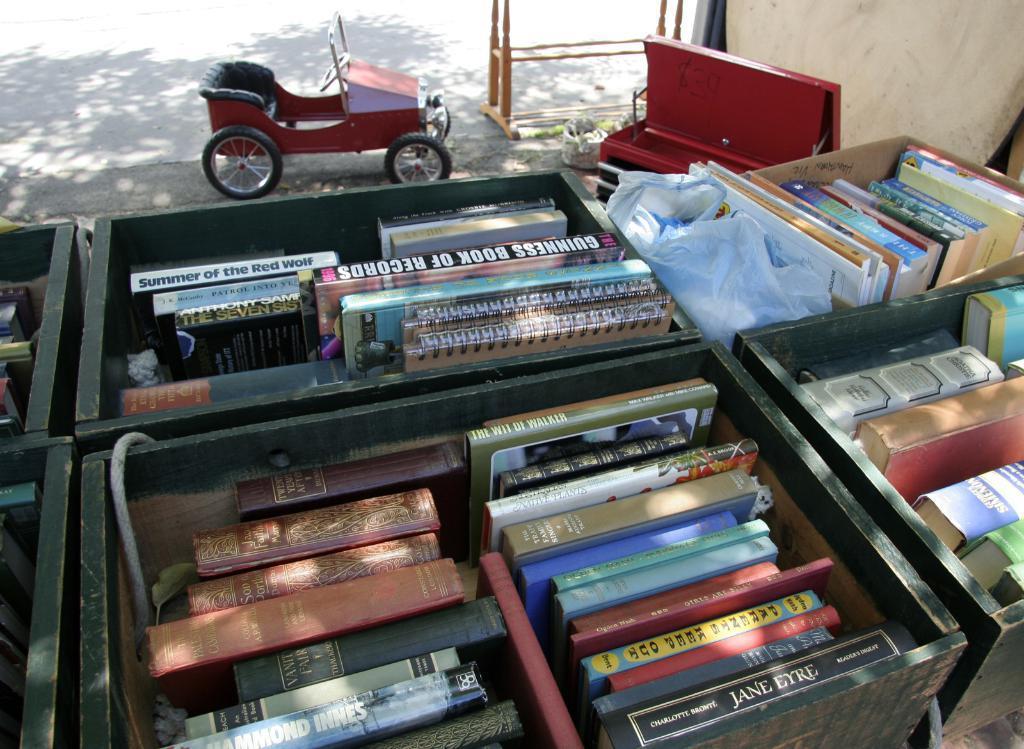Could you give a brief overview of what you see in this image? In this image I can see few books in the boxes and the books are in multi color, background I can see the vehicle in red color and I can see some wooden object. 